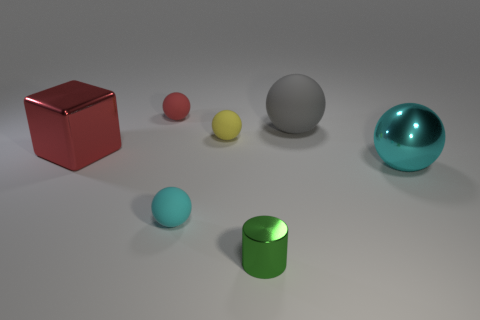What number of other things are the same shape as the large red metallic thing?
Give a very brief answer. 0. Are there more green metallic objects than rubber balls?
Make the answer very short. No. There is a metal object to the left of the small yellow rubber ball on the right side of the sphere that is behind the gray rubber ball; how big is it?
Offer a terse response. Large. There is a cyan object that is to the left of the gray thing; what is its size?
Your response must be concise. Small. How many things are large metal spheres or objects that are in front of the large cyan metal ball?
Provide a short and direct response. 3. How many other objects are the same size as the cyan metal object?
Provide a short and direct response. 2. There is a large cyan object that is the same shape as the tiny yellow object; what is it made of?
Provide a short and direct response. Metal. Is the number of tiny red objects that are behind the large rubber object greater than the number of small green balls?
Your answer should be very brief. Yes. Is there any other thing that has the same color as the tiny metal cylinder?
Keep it short and to the point. No. There is a tiny green thing that is the same material as the big red object; what is its shape?
Ensure brevity in your answer.  Cylinder. 